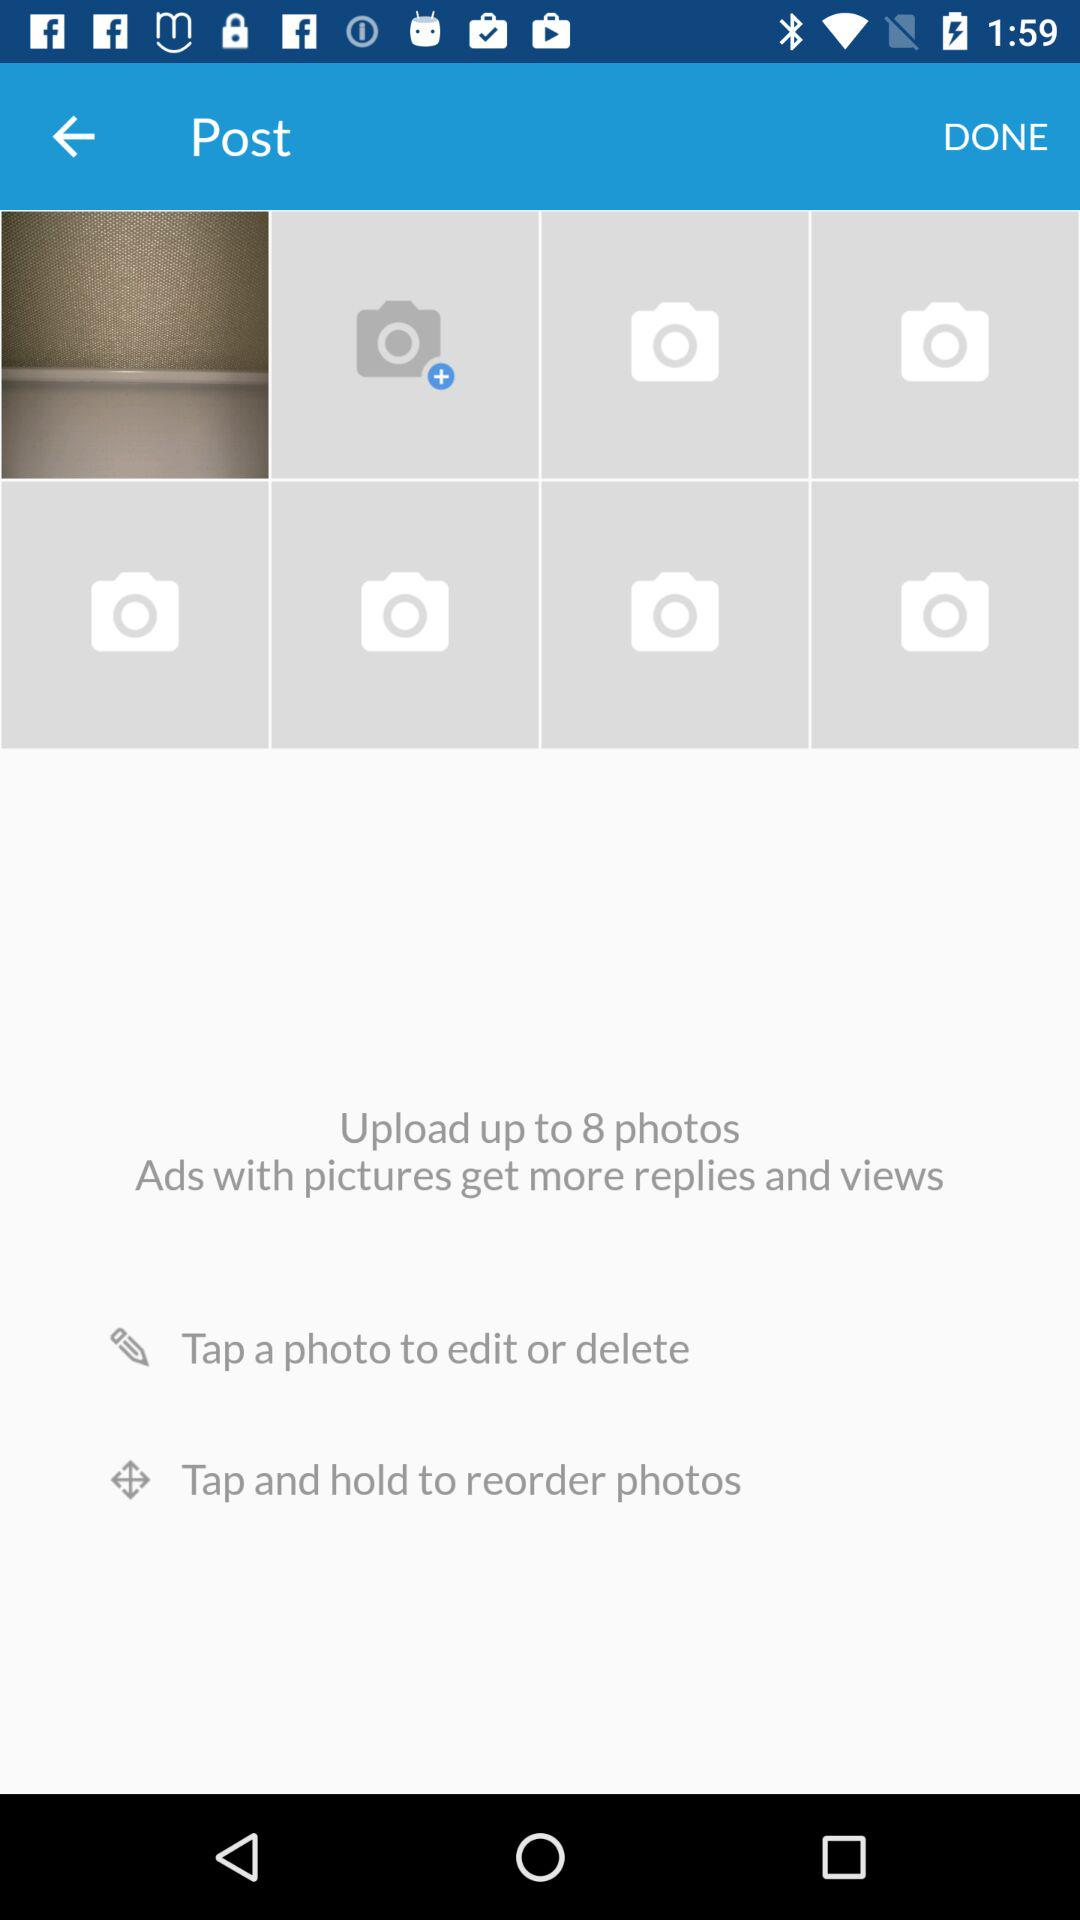How many photos are uploaded? How many photos can be uploaded? You can upload up to 8 photos. 